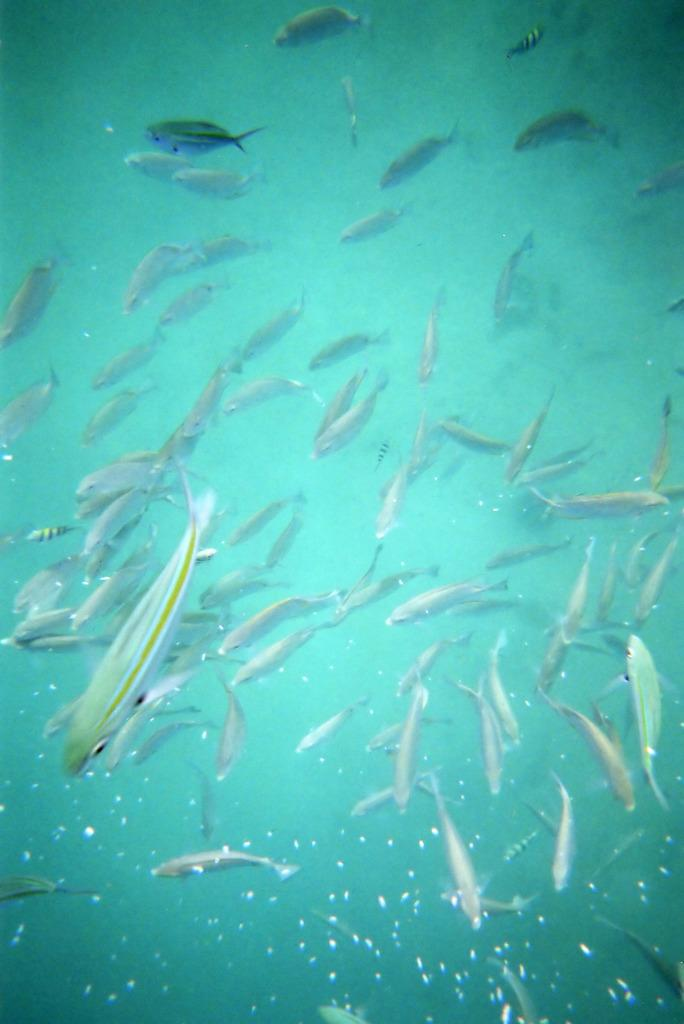What type of animals can be seen in the image? There are fishes in the water. How are the fishes distributed in the image? The fishes are spread throughout the image. What type of machine can be seen operating in the image? There is no machine present in the image; it features fishes in the water. Can you describe the train tracks visible in the image? There are no train tracks present in the image. 